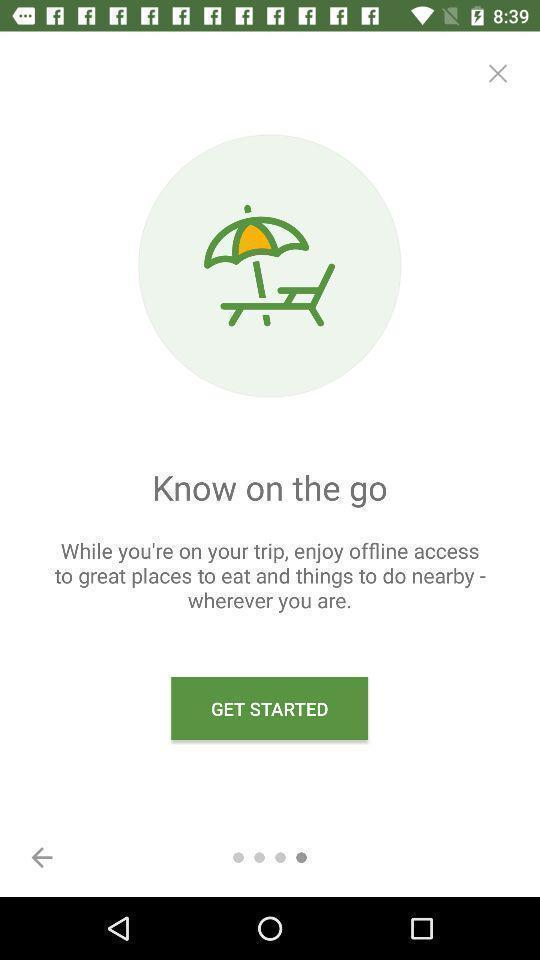Provide a detailed account of this screenshot. Welcome page for a travel app. 